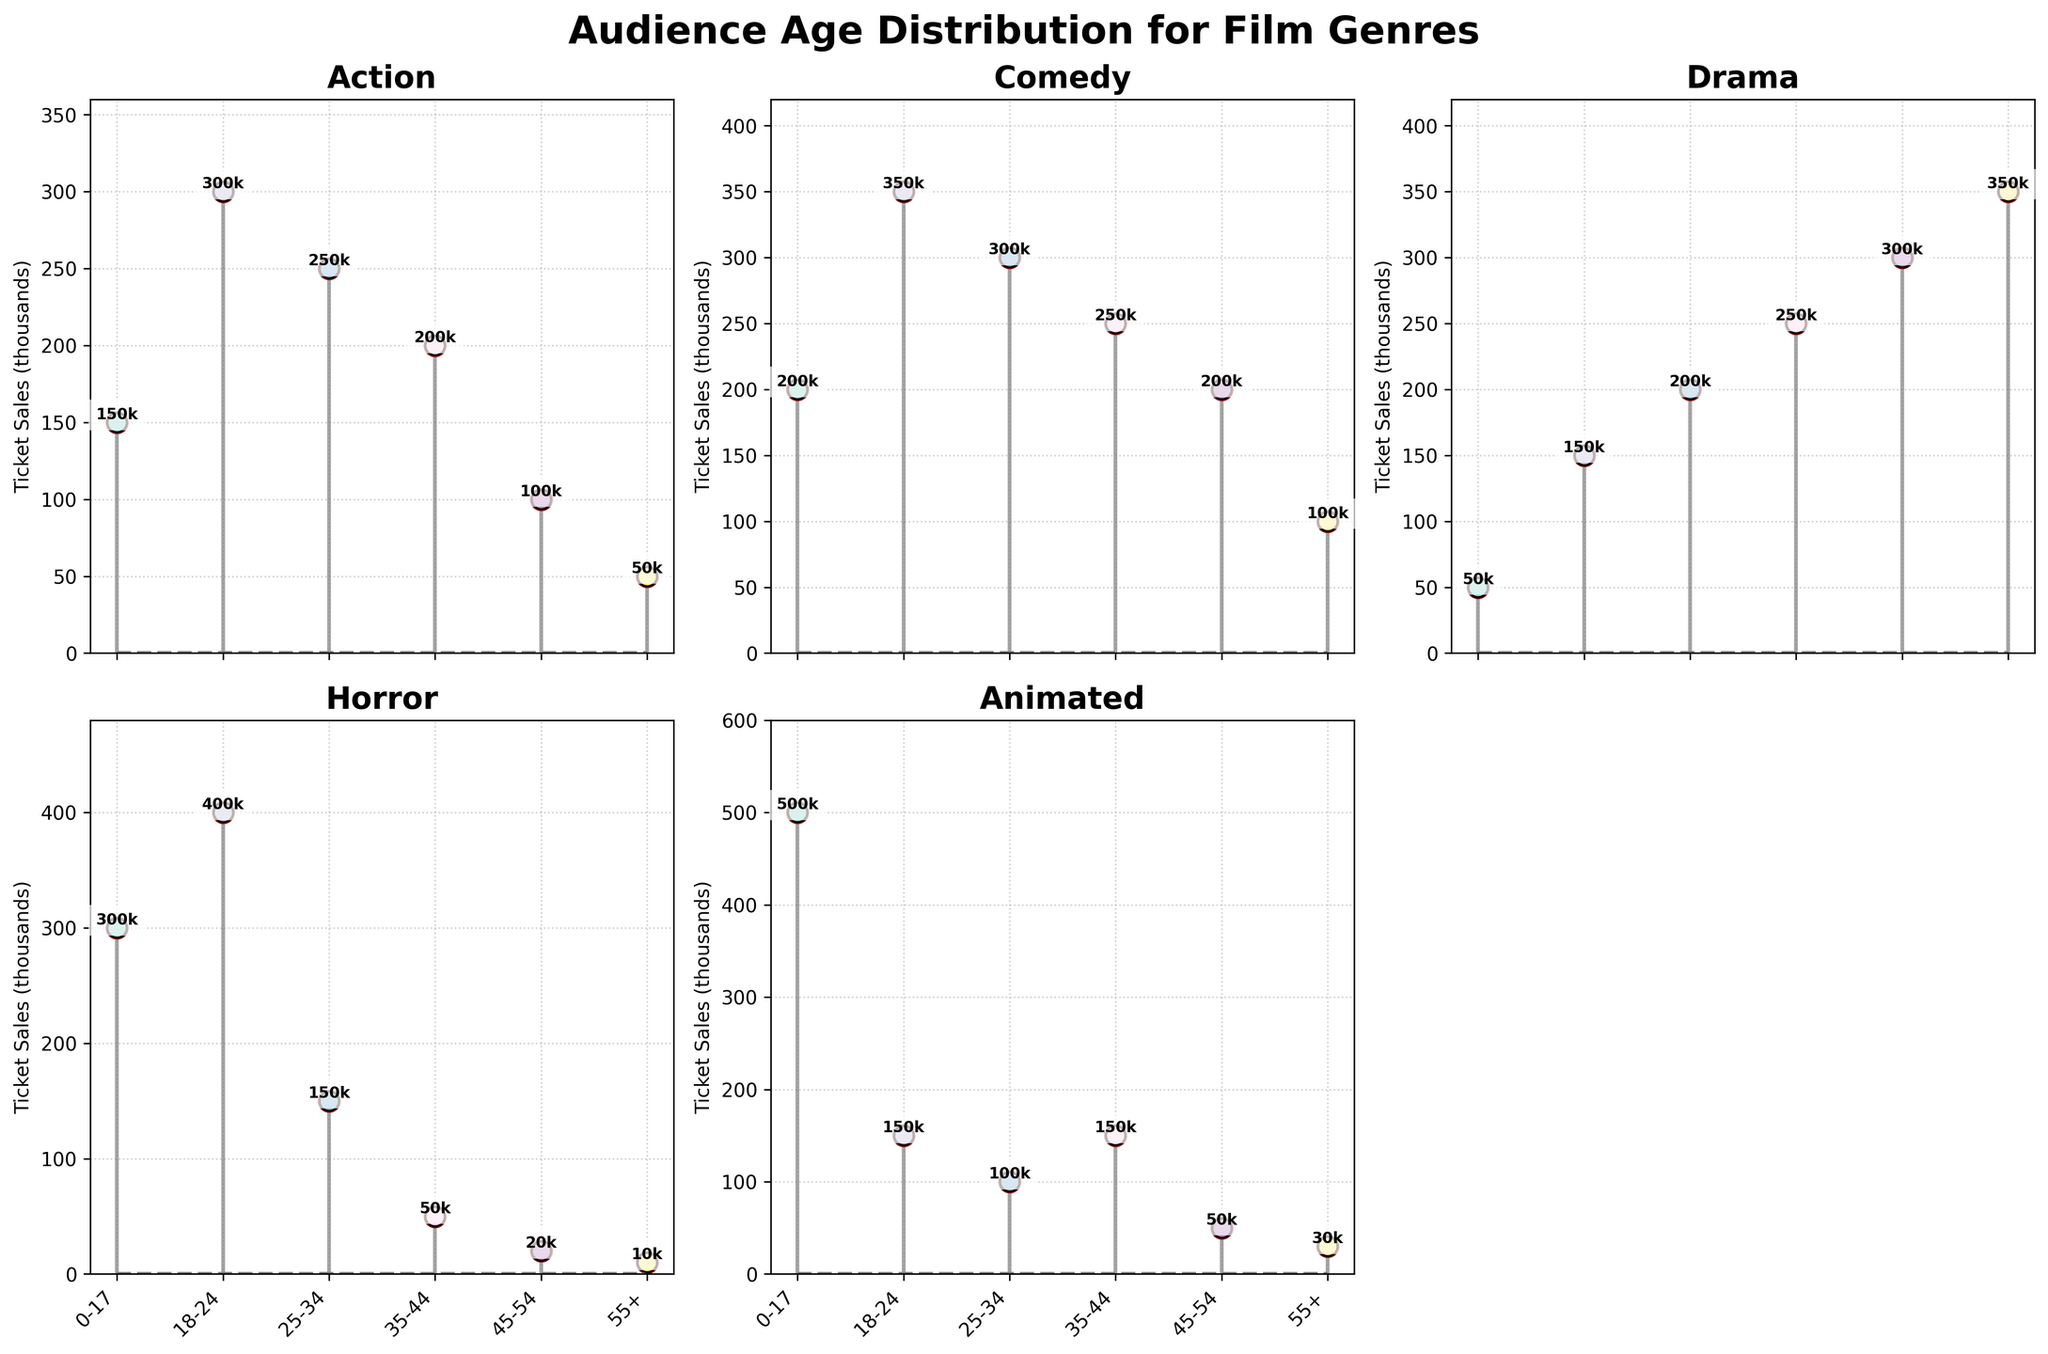What's the most popular age group for Action films? By observing Action films' data points, the highest stem plot point corresponds to the 18-24 age group with 300 thousand ticket sales.
Answer: 18-24 Which genre attracts the oldest audience? By observing the peaks in the '55+' age group across subplots, Drama has the highest ticket sales with 350 thousand in that age group.
Answer: Drama What is the difference in ticket sales between the 18-24 and 25-34 age groups for Comedy films? Comedy films' data points show 350 thousand tickets for the 18-24 age group and 300 thousand for the 25-34 age group. The difference is 350 - 300 = 50 thousand tickets.
Answer: 50 thousand Which genre has the lowest ticket sales among all age groups combined? Summing up all ticket sales for each subplot/genre: 
Action: 150 + 300 + 250 + 200 + 100 + 50 = 1050 thousand
Comedy: 200 + 350 + 300 + 250 + 200 + 100 = 1400 thousand
Drama: 50 + 150 + 200 + 250 + 300 + 350 = 1300 thousand
Horror: 300 + 400 + 150 + 50 + 20 + 10 = 930 thousand
Animated: 500 + 150 + 100 + 150 + 50 + 30 = 980 thousand The genre with lowest combined ticket sales is Horror with 930 thousand.
Answer: Horror Which age group buys more tickets for Animated films, 0-17 or 35-44? In the subplot for Animated films, the 0-17 age group has 500 thousand ticket sales, and the 35-44 age group has 150 thousand.
Answer: 0-17 What is the total ticket sales for the 0-17 age group across all genres? Summing up 0-17 ticket sales:
Action: 150
Comedy: 200
Drama: 50
Horror: 300
Animated: 500
Total: 150 + 200 + 50 + 300 + 500 = 1200 thousand
Answer: 1200 thousand How do ticket sales for Drama films compare between the 35-44 and 55+ age groups? Observing the subplot for Drama films, 35-44 has 250 thousand ticket sales whereas 55+ has 350 thousand, making the 55+ age group higher.
Answer: 55+ Which film genre has the most balanced ticket sales distribution across different age groups, and why? The subplot for Comedy shows a more even distribution, with ticket sales ranging from 100 to 350 thousand and a smaller gap between age groups compared to other genres.
Answer: Comedy 